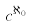Convert formula to latex. <formula><loc_0><loc_0><loc_500><loc_500>c ^ { \aleph _ { 0 } }</formula> 